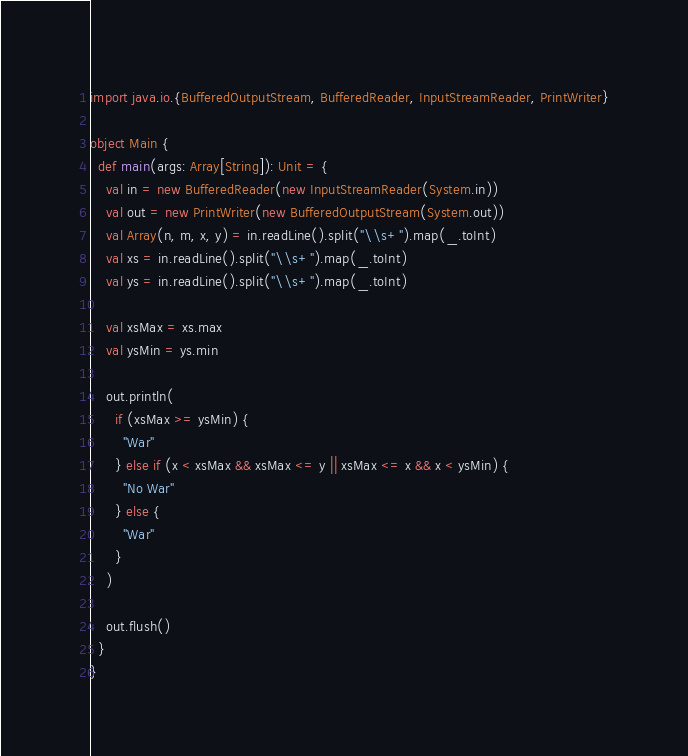<code> <loc_0><loc_0><loc_500><loc_500><_Scala_>import java.io.{BufferedOutputStream, BufferedReader, InputStreamReader, PrintWriter}

object Main {
  def main(args: Array[String]): Unit = {
    val in = new BufferedReader(new InputStreamReader(System.in))
    val out = new PrintWriter(new BufferedOutputStream(System.out))
    val Array(n, m, x, y) = in.readLine().split("\\s+").map(_.toInt)
    val xs = in.readLine().split("\\s+").map(_.toInt)
    val ys = in.readLine().split("\\s+").map(_.toInt)

    val xsMax = xs.max
    val ysMin = ys.min

    out.println(
      if (xsMax >= ysMin) {
        "War"
      } else if (x < xsMax && xsMax <= y || xsMax <= x && x < ysMin) {
        "No War"
      } else {
        "War"
      }
    )

    out.flush()
  }
}
</code> 